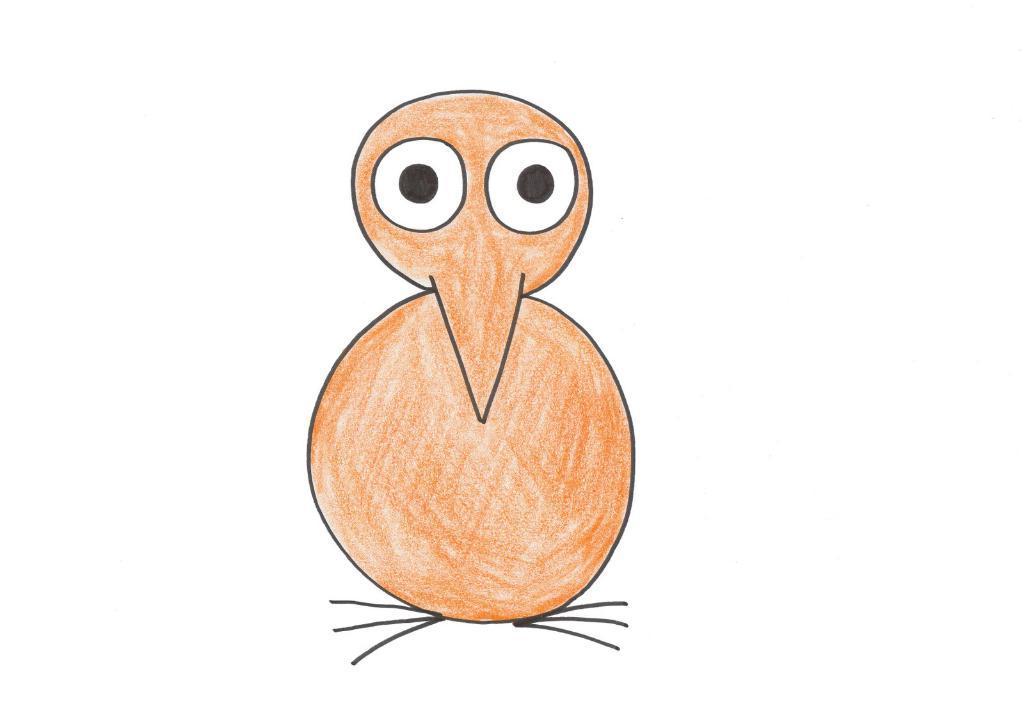Can you describe this image briefly? This is a painting of a bird having two eyes, a nose and legs. And the background is white in color. 